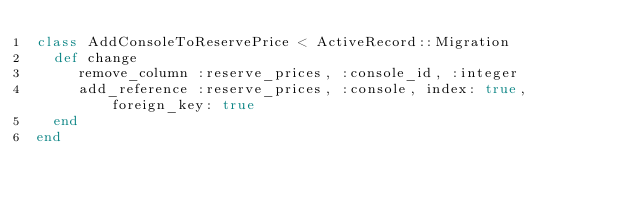Convert code to text. <code><loc_0><loc_0><loc_500><loc_500><_Ruby_>class AddConsoleToReservePrice < ActiveRecord::Migration
  def change
     remove_column :reserve_prices, :console_id, :integer
     add_reference :reserve_prices, :console, index: true, foreign_key: true
  end
end
</code> 